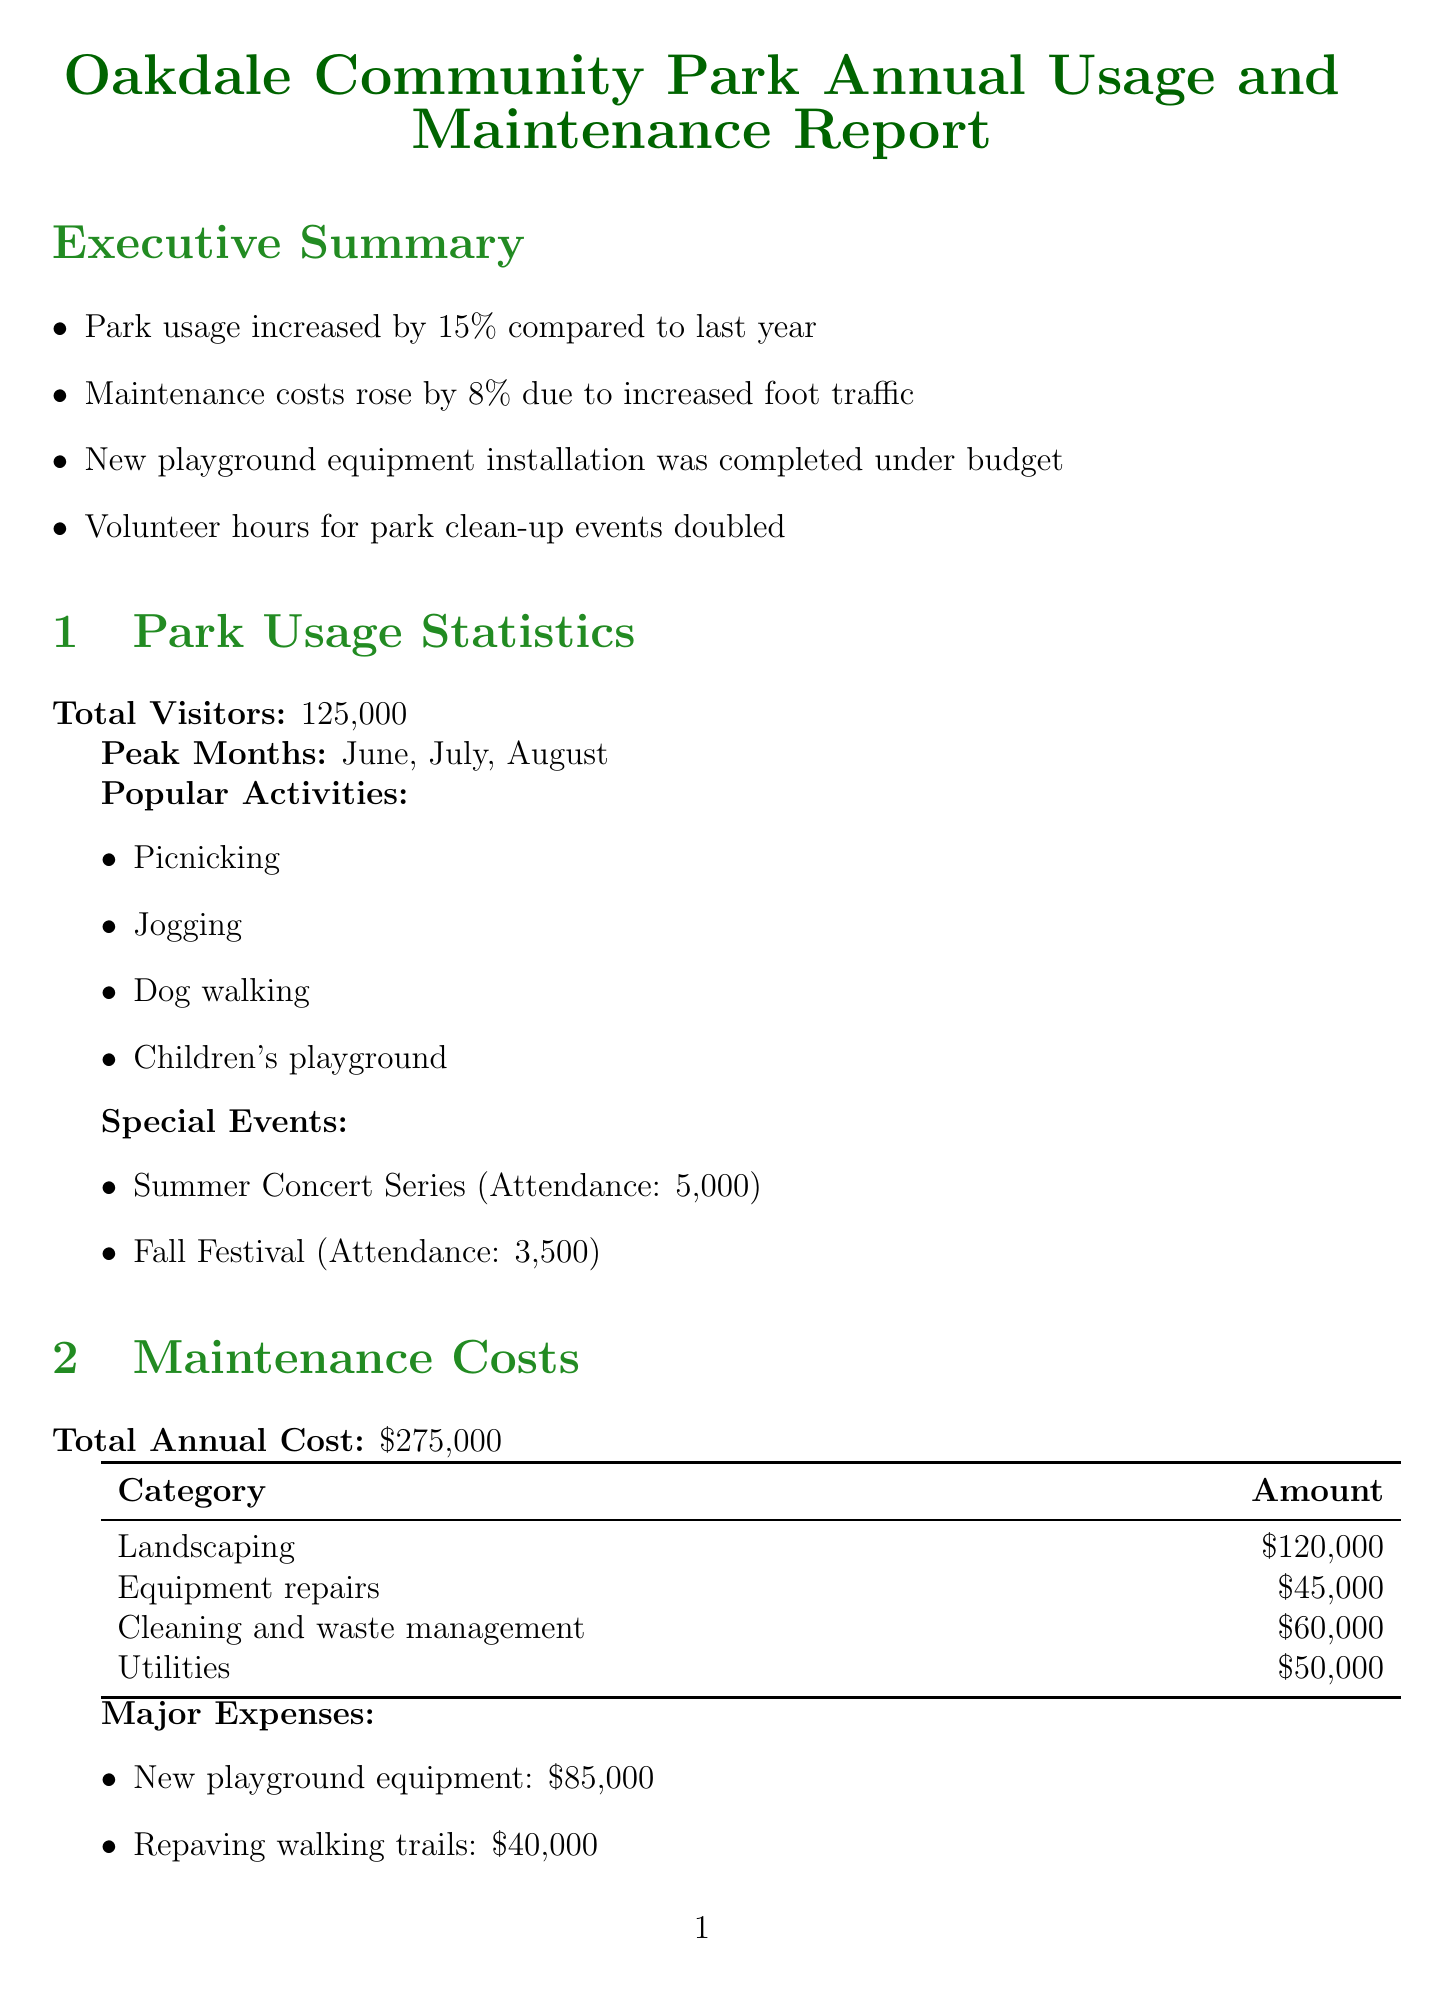What was the increase in park usage compared to last year? The report states that park usage increased by 15% compared to last year.
Answer: 15% What is the total annual maintenance cost? The total annual maintenance cost is explicitly mentioned in the document as $275,000.
Answer: $275,000 Which months had the highest park attendance? The peak months for park usage listed in the document are June, July, and August.
Answer: June, July, August How many volunteer hours were reported for community involvement? The document notes that there were 2,500 volunteer hours recorded for park clean-up events.
Answer: 2,500 What were the major expenses in maintenance costs? The major expenses were given as new playground equipment costing $85,000 and repaving walking trails costing $40,000.
Answer: New playground equipment: $85,000; Repaving walking trails: $40,000 What type of events increased volunteer hours? The document mentions that the park clean-up events led to a doubling of volunteer hours.
Answer: Park clean-up events What are the proposed projects for future park improvements? The proposed projects include installation of a water-efficient irrigation system, expansion of the dog park area, and addition of outdoor fitness equipment stations.
Answer: Installation of water-efficient irrigation system, Expansion of the dog park area, Addition of outdoor fitness equipment stations Who is the park manager? The contact information section states that the park manager is Sarah Thompson.
Answer: Sarah Thompson 